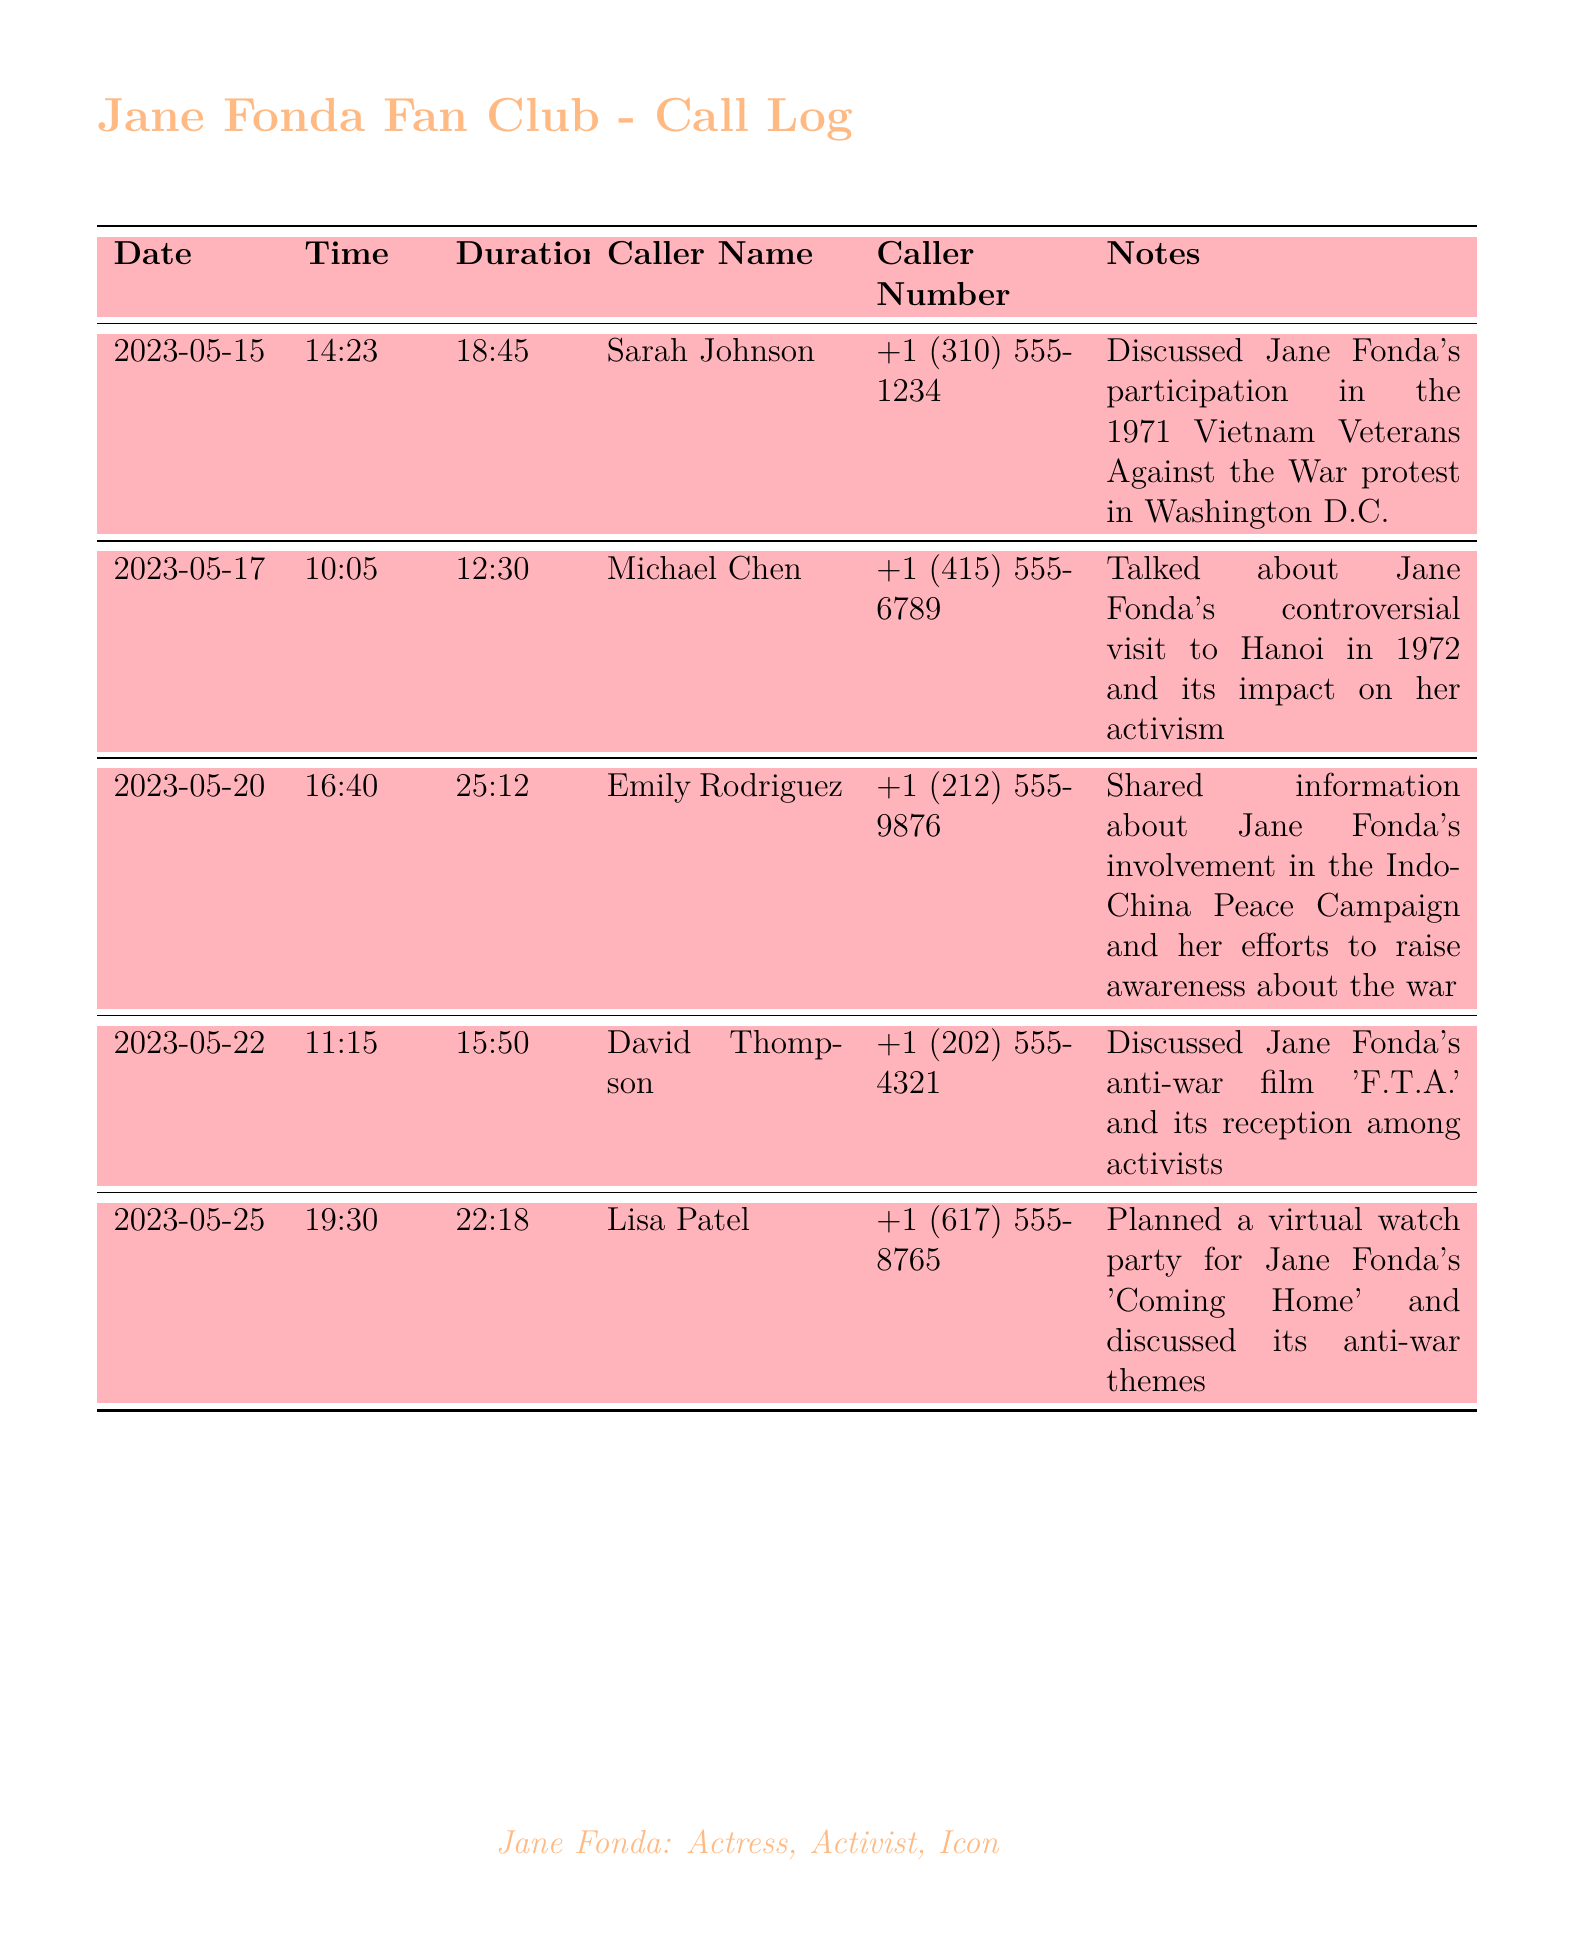What is the date of the first call? The first call in the log is recorded on May 15, 2023.
Answer: May 15, 2023 Who was the caller for the conversation about Jane Fonda's film 'F.T.A.'? The conversation about 'F.T.A.' was with David Thompson.
Answer: David Thompson What was the duration of the call made by Emily Rodriguez? The duration of Emily Rodriguez's call was 25 minutes and 12 seconds.
Answer: 25:12 How many calls were made in total? There are five entries in the call log, representing five calls.
Answer: 5 What event was discussed in the call with Sarah Johnson? Sarah Johnson discussed Jane Fonda's participation in the Vietnam Veterans Against the War protest.
Answer: Vietnam Veterans Against the War protest What was the main topic of the call with Michael Chen? The main topic was Jane Fonda's controversial visit to Hanoi in 1972.
Answer: Controversial visit to Hanoi in 1972 What time did Lisa Patel's call take place? Lisa Patel's call took place at 19:30.
Answer: 19:30 What was planned during the call with Lisa Patel? A virtual watch party for Jane Fonda's 'Coming Home' was planned.
Answer: Virtual watch party 